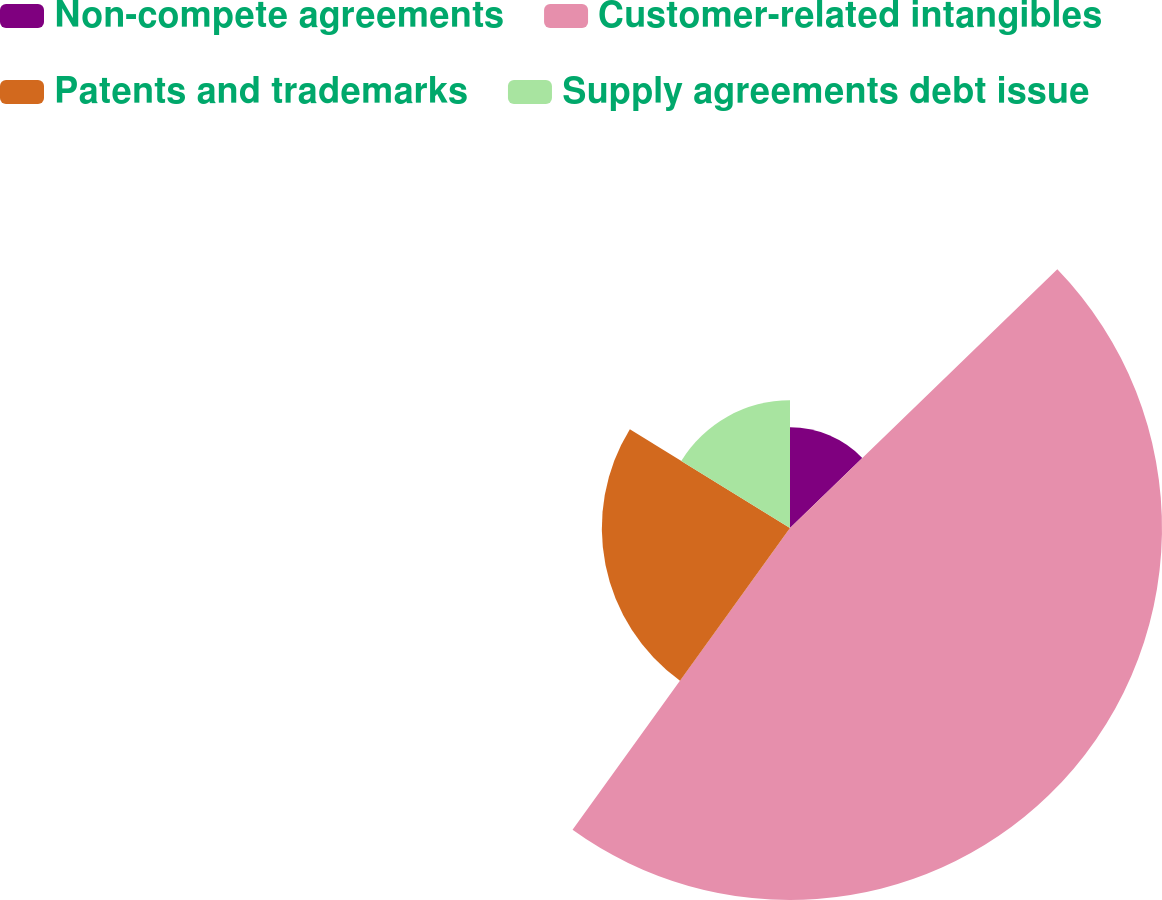<chart> <loc_0><loc_0><loc_500><loc_500><pie_chart><fcel>Non-compete agreements<fcel>Customer-related intangibles<fcel>Patents and trademarks<fcel>Supply agreements debt issue<nl><fcel>12.76%<fcel>47.17%<fcel>23.86%<fcel>16.2%<nl></chart> 